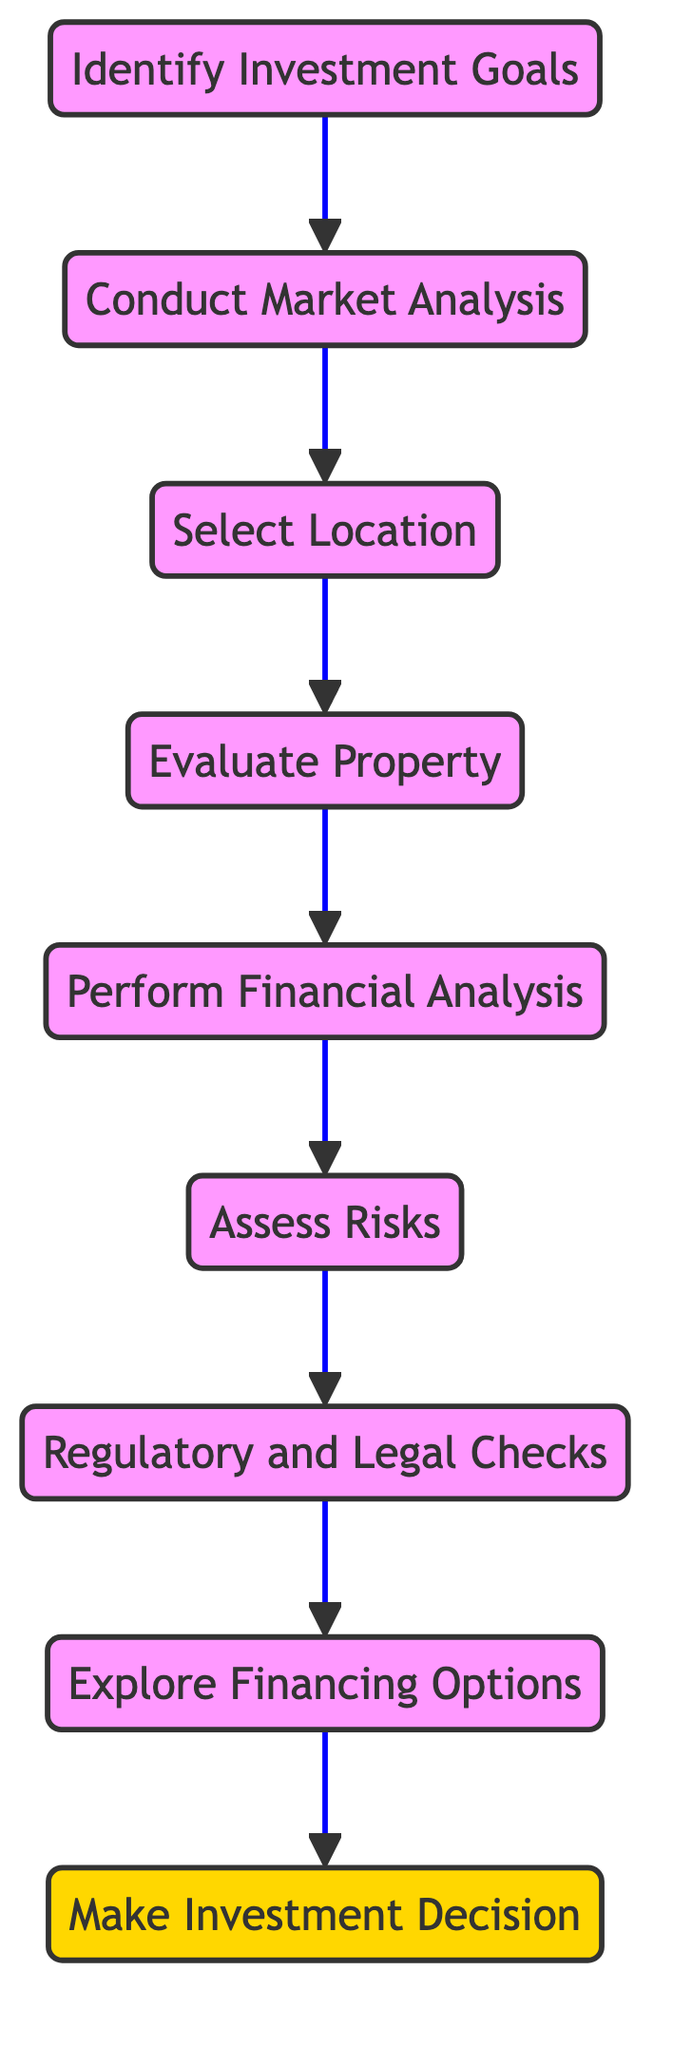What is the first step in the investment decision process? The diagram starts with the node labeled "Identify Investment Goals," which indicates this is the first step in the process.
Answer: Identify Investment Goals How many nodes are present in the diagram? Counting the listed nodes in the data, there are eight unique nodes: identify_goals, market_analysis, financial_analysis, risk_assessment, location_selection, property_evaluation, investment_decision, regulatory_checks, financing_options.
Answer: Eight Which node follows the "Assess Risks" node? The diagram shows an edge from "Assess Risks" to "Regulatory and Legal Checks," meaning "Regulatory and Legal Checks" is the subsequent node that follows "Assess Risks."
Answer: Regulatory and Legal Checks What is the last step before making an investment decision? The final node before "Make Investment Decision" is "Explore Financing Options," as indicated by the edge leading to the investment decision node.
Answer: Explore Financing Options How many edges are there in total? The data provides a list of edges connecting the nodes; there are a total of eight edges shown in the data.
Answer: Eight What is the relationship between "Conduct Market Analysis" and "Select Location"? The diagram indicates a direct connection from "Conduct Market Analysis" to "Select Location," meaning the next step after conducting market analysis is selecting a location.
Answer: Next What comes directly after "Evaluate Property" in the decision process? According to the diagram's flow, the node that follows "Evaluate Property" is "Perform Financial Analysis," establishing the relationship in the process.
Answer: Perform Financial Analysis Which node is classified as a decision point? The node labeled "Make Investment Decision" is marked as a decision point, distinct from the other nodes, indicating it requires making a choice based on previous analyses.
Answer: Make Investment Decision 